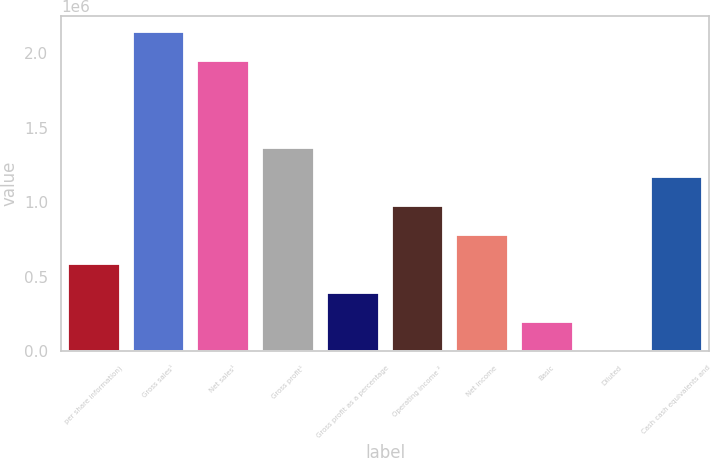<chart> <loc_0><loc_0><loc_500><loc_500><bar_chart><fcel>per share information)<fcel>Gross sales¹<fcel>Net sales¹<fcel>Gross profit¹<fcel>Gross profit as a percentage<fcel>Operating income ²<fcel>Net income<fcel>Basic<fcel>Diluted<fcel>Cash cash equivalents and<nl><fcel>585148<fcel>2.14554e+06<fcel>1.95049e+06<fcel>1.36534e+06<fcel>390099<fcel>975246<fcel>780197<fcel>195050<fcel>1.53<fcel>1.17029e+06<nl></chart> 